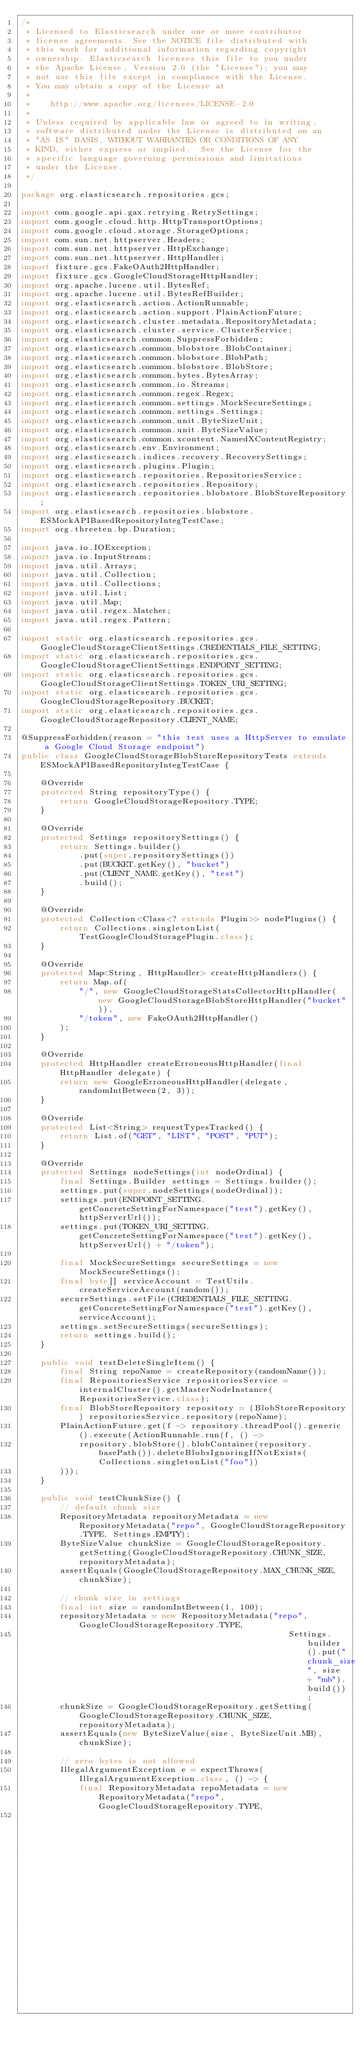<code> <loc_0><loc_0><loc_500><loc_500><_Java_>/*
 * Licensed to Elasticsearch under one or more contributor
 * license agreements. See the NOTICE file distributed with
 * this work for additional information regarding copyright
 * ownership. Elasticsearch licenses this file to you under
 * the Apache License, Version 2.0 (the "License"); you may
 * not use this file except in compliance with the License.
 * You may obtain a copy of the License at
 *
 *    http://www.apache.org/licenses/LICENSE-2.0
 *
 * Unless required by applicable law or agreed to in writing,
 * software distributed under the License is distributed on an
 * "AS IS" BASIS, WITHOUT WARRANTIES OR CONDITIONS OF ANY
 * KIND, either express or implied.  See the License for the
 * specific language governing permissions and limitations
 * under the License.
 */

package org.elasticsearch.repositories.gcs;

import com.google.api.gax.retrying.RetrySettings;
import com.google.cloud.http.HttpTransportOptions;
import com.google.cloud.storage.StorageOptions;
import com.sun.net.httpserver.Headers;
import com.sun.net.httpserver.HttpExchange;
import com.sun.net.httpserver.HttpHandler;
import fixture.gcs.FakeOAuth2HttpHandler;
import fixture.gcs.GoogleCloudStorageHttpHandler;
import org.apache.lucene.util.BytesRef;
import org.apache.lucene.util.BytesRefBuilder;
import org.elasticsearch.action.ActionRunnable;
import org.elasticsearch.action.support.PlainActionFuture;
import org.elasticsearch.cluster.metadata.RepositoryMetadata;
import org.elasticsearch.cluster.service.ClusterService;
import org.elasticsearch.common.SuppressForbidden;
import org.elasticsearch.common.blobstore.BlobContainer;
import org.elasticsearch.common.blobstore.BlobPath;
import org.elasticsearch.common.blobstore.BlobStore;
import org.elasticsearch.common.bytes.BytesArray;
import org.elasticsearch.common.io.Streams;
import org.elasticsearch.common.regex.Regex;
import org.elasticsearch.common.settings.MockSecureSettings;
import org.elasticsearch.common.settings.Settings;
import org.elasticsearch.common.unit.ByteSizeUnit;
import org.elasticsearch.common.unit.ByteSizeValue;
import org.elasticsearch.common.xcontent.NamedXContentRegistry;
import org.elasticsearch.env.Environment;
import org.elasticsearch.indices.recovery.RecoverySettings;
import org.elasticsearch.plugins.Plugin;
import org.elasticsearch.repositories.RepositoriesService;
import org.elasticsearch.repositories.Repository;
import org.elasticsearch.repositories.blobstore.BlobStoreRepository;
import org.elasticsearch.repositories.blobstore.ESMockAPIBasedRepositoryIntegTestCase;
import org.threeten.bp.Duration;

import java.io.IOException;
import java.io.InputStream;
import java.util.Arrays;
import java.util.Collection;
import java.util.Collections;
import java.util.List;
import java.util.Map;
import java.util.regex.Matcher;
import java.util.regex.Pattern;

import static org.elasticsearch.repositories.gcs.GoogleCloudStorageClientSettings.CREDENTIALS_FILE_SETTING;
import static org.elasticsearch.repositories.gcs.GoogleCloudStorageClientSettings.ENDPOINT_SETTING;
import static org.elasticsearch.repositories.gcs.GoogleCloudStorageClientSettings.TOKEN_URI_SETTING;
import static org.elasticsearch.repositories.gcs.GoogleCloudStorageRepository.BUCKET;
import static org.elasticsearch.repositories.gcs.GoogleCloudStorageRepository.CLIENT_NAME;

@SuppressForbidden(reason = "this test uses a HttpServer to emulate a Google Cloud Storage endpoint")
public class GoogleCloudStorageBlobStoreRepositoryTests extends ESMockAPIBasedRepositoryIntegTestCase {

    @Override
    protected String repositoryType() {
        return GoogleCloudStorageRepository.TYPE;
    }

    @Override
    protected Settings repositorySettings() {
        return Settings.builder()
            .put(super.repositorySettings())
            .put(BUCKET.getKey(), "bucket")
            .put(CLIENT_NAME.getKey(), "test")
            .build();
    }

    @Override
    protected Collection<Class<? extends Plugin>> nodePlugins() {
        return Collections.singletonList(TestGoogleCloudStoragePlugin.class);
    }

    @Override
    protected Map<String, HttpHandler> createHttpHandlers() {
        return Map.of(
            "/", new GoogleCloudStorageStatsCollectorHttpHandler(new GoogleCloudStorageBlobStoreHttpHandler("bucket")),
            "/token", new FakeOAuth2HttpHandler()
        );
    }

    @Override
    protected HttpHandler createErroneousHttpHandler(final HttpHandler delegate) {
        return new GoogleErroneousHttpHandler(delegate, randomIntBetween(2, 3));
    }

    @Override
    protected List<String> requestTypesTracked() {
        return List.of("GET", "LIST", "POST", "PUT");
    }

    @Override
    protected Settings nodeSettings(int nodeOrdinal) {
        final Settings.Builder settings = Settings.builder();
        settings.put(super.nodeSettings(nodeOrdinal));
        settings.put(ENDPOINT_SETTING.getConcreteSettingForNamespace("test").getKey(), httpServerUrl());
        settings.put(TOKEN_URI_SETTING.getConcreteSettingForNamespace("test").getKey(), httpServerUrl() + "/token");

        final MockSecureSettings secureSettings = new MockSecureSettings();
        final byte[] serviceAccount = TestUtils.createServiceAccount(random());
        secureSettings.setFile(CREDENTIALS_FILE_SETTING.getConcreteSettingForNamespace("test").getKey(), serviceAccount);
        settings.setSecureSettings(secureSettings);
        return settings.build();
    }

    public void testDeleteSingleItem() {
        final String repoName = createRepository(randomName());
        final RepositoriesService repositoriesService = internalCluster().getMasterNodeInstance(RepositoriesService.class);
        final BlobStoreRepository repository = (BlobStoreRepository) repositoriesService.repository(repoName);
        PlainActionFuture.get(f -> repository.threadPool().generic().execute(ActionRunnable.run(f, () ->
            repository.blobStore().blobContainer(repository.basePath()).deleteBlobsIgnoringIfNotExists(Collections.singletonList("foo"))
        )));
    }

    public void testChunkSize() {
        // default chunk size
        RepositoryMetadata repositoryMetadata = new RepositoryMetadata("repo", GoogleCloudStorageRepository.TYPE, Settings.EMPTY);
        ByteSizeValue chunkSize = GoogleCloudStorageRepository.getSetting(GoogleCloudStorageRepository.CHUNK_SIZE, repositoryMetadata);
        assertEquals(GoogleCloudStorageRepository.MAX_CHUNK_SIZE, chunkSize);

        // chunk size in settings
        final int size = randomIntBetween(1, 100);
        repositoryMetadata = new RepositoryMetadata("repo", GoogleCloudStorageRepository.TYPE,
                                                       Settings.builder().put("chunk_size", size + "mb").build());
        chunkSize = GoogleCloudStorageRepository.getSetting(GoogleCloudStorageRepository.CHUNK_SIZE, repositoryMetadata);
        assertEquals(new ByteSizeValue(size, ByteSizeUnit.MB), chunkSize);

        // zero bytes is not allowed
        IllegalArgumentException e = expectThrows(IllegalArgumentException.class, () -> {
            final RepositoryMetadata repoMetadata = new RepositoryMetadata("repo", GoogleCloudStorageRepository.TYPE,
                                                                        Settings.builder().put("chunk_size", "0").build());</code> 